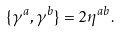Convert formula to latex. <formula><loc_0><loc_0><loc_500><loc_500>\{ \gamma ^ { a } , \gamma ^ { b } \} = 2 \eta ^ { a b } .</formula> 